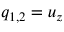Convert formula to latex. <formula><loc_0><loc_0><loc_500><loc_500>q _ { 1 , 2 } = u _ { z }</formula> 